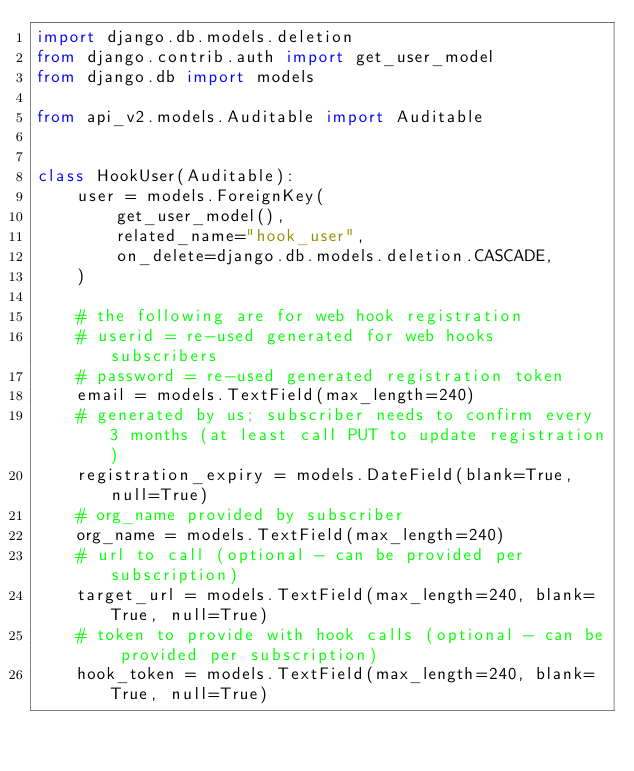Convert code to text. <code><loc_0><loc_0><loc_500><loc_500><_Python_>import django.db.models.deletion
from django.contrib.auth import get_user_model
from django.db import models

from api_v2.models.Auditable import Auditable


class HookUser(Auditable):
    user = models.ForeignKey(
        get_user_model(),
        related_name="hook_user",
        on_delete=django.db.models.deletion.CASCADE,
    )

    # the following are for web hook registration
    # userid = re-used generated for web hooks subscribers
    # password = re-used generated registration token
    email = models.TextField(max_length=240)
    # generated by us; subscriber needs to confirm every 3 months (at least call PUT to update registration)
    registration_expiry = models.DateField(blank=True, null=True)
    # org_name provided by subscriber
    org_name = models.TextField(max_length=240)
    # url to call (optional - can be provided per subscription)
    target_url = models.TextField(max_length=240, blank=True, null=True)
    # token to provide with hook calls (optional - can be provided per subscription)
    hook_token = models.TextField(max_length=240, blank=True, null=True)
</code> 